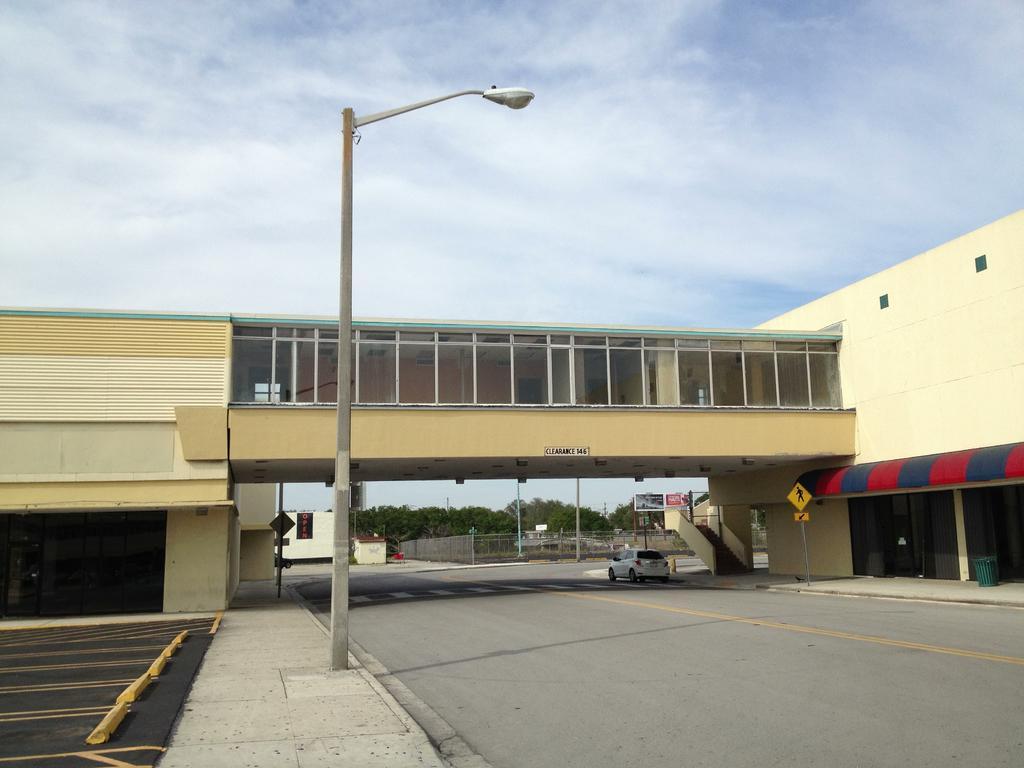Please provide a concise description of this image. In this image we can see a group of buildings with glass doors. In the center of the image we can see a vehicle parked on the road, a bridge and a fence. On the right side of the image we can see signboard, trash bin placed on the ground. In the foreground we can see light pole. In the background, we can see a group of trees, poles. At the top of the image we can see the cloudy sky. 